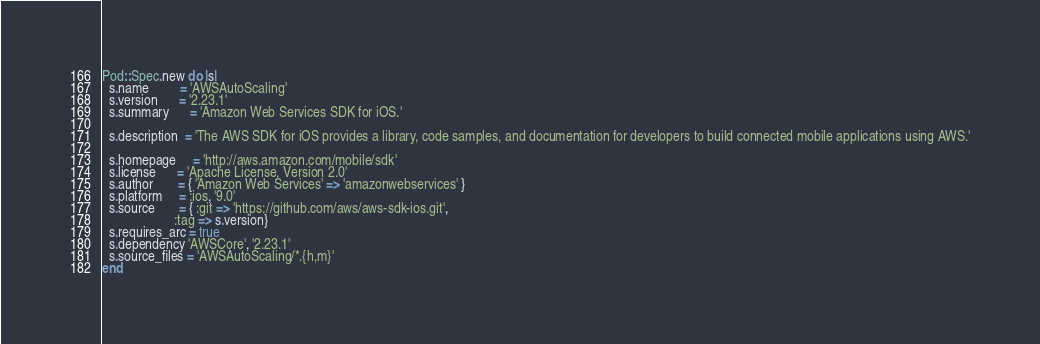<code> <loc_0><loc_0><loc_500><loc_500><_Ruby_>Pod::Spec.new do |s|
  s.name         = 'AWSAutoScaling'
  s.version      = '2.23.1'
  s.summary      = 'Amazon Web Services SDK for iOS.'

  s.description  = 'The AWS SDK for iOS provides a library, code samples, and documentation for developers to build connected mobile applications using AWS.'

  s.homepage     = 'http://aws.amazon.com/mobile/sdk'
  s.license      = 'Apache License, Version 2.0'
  s.author       = { 'Amazon Web Services' => 'amazonwebservices' }
  s.platform     = :ios, '9.0'
  s.source       = { :git => 'https://github.com/aws/aws-sdk-ios.git',
                     :tag => s.version}
  s.requires_arc = true
  s.dependency 'AWSCore', '2.23.1'
  s.source_files = 'AWSAutoScaling/*.{h,m}'
end
</code> 